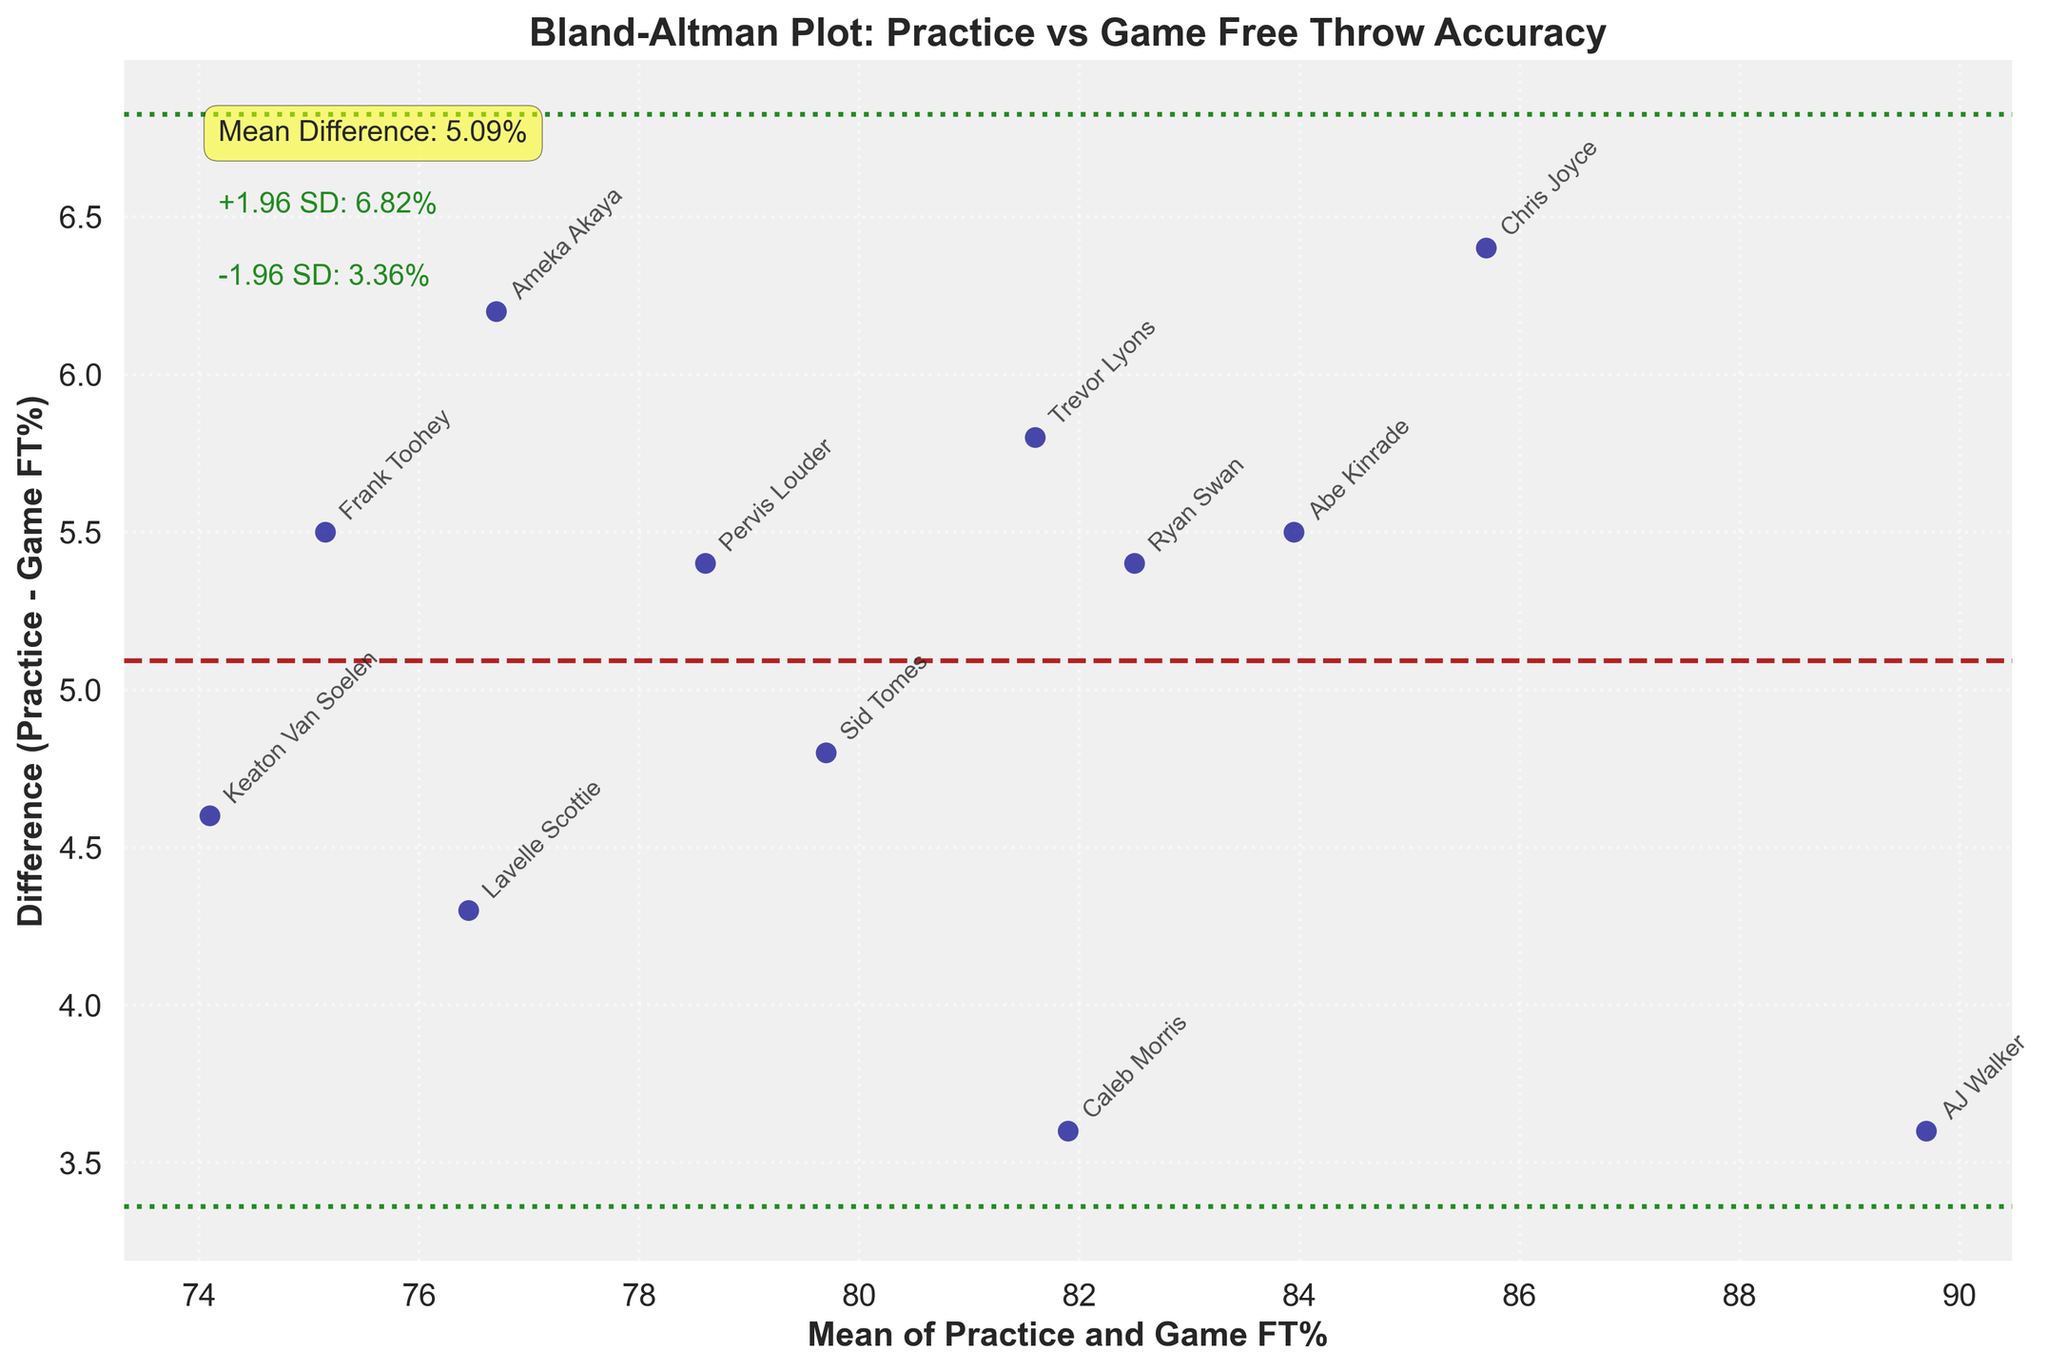What is the overall title of the Bland-Altman plot? The title of the plot is usually displayed at the top. According to the data, it should be clear that the title reflects the content of the figure, which compares practice and game free throw accuracy.
Answer: Bland-Altman Plot: Practice vs Game Free Throw Accuracy What does the x-axis represent in the plot? The x-axis usually represents one of the variables being compared. In this case, it shows the Mean of Practice and Game FT%, which corresponds to the average free throw percentage in both practice and game for each player.
Answer: Mean of Practice and Game FT% What is the range of the y-axis in the Bland-Altman plot? To determine the range of the y-axis, one needs to look at the visual extremes of the differences between practice and game free throw percentages. This range often includes both positive and negative values.
Answer: Approximately from -6% to 8% How many data points are plotted in the Bland-Altman plot? Each point on the graph represents a player, and the number of points corresponds to the number of players listed in the data. Count the number of players to derive this number.
Answer: 12 What is the mean difference between practice and game FT percentages? The mean difference (md) is typically indicated by a horizontal line and often comes with an annotation. It shows the average of the differences between practice and game FT%. Look for the value labeled as Mean Difference next to the horizontal line.
Answer: 4.56% What do the green dashed lines represent? The two green dashed lines on the plot indicate the limits of agreement, which are calculated as the mean difference plus and minus 1.96 times the standard deviation of the differences.
Answer: Limits of agreement Which player has the largest positive difference between Practice and Game FT%? To find the player with the largest positive difference, identify the highest point on the y-axis (difference) and refer to the associated player label.
Answer: AJ Walker Are there any players with a negative difference? If yes, who are they? To determine if there are any players with a negative difference, look at points on the graph below the horizontal zero line and note their labels.
Answer: Lavelle Scottie and Ameka Akaya Which player has the closest FT percentages between practice and games? The player with the smallest absolute difference would be closest to the zero line on the plot. Identify this point and note the corresponding player label.
Answer: Caleb Morris Do most players have higher FT percentages in practice or in games? Assess whether most points lie above or below the zero difference line. If above, most players have higher percentages in practice; if below, higher in games.
Answer: Most have higher in practice 